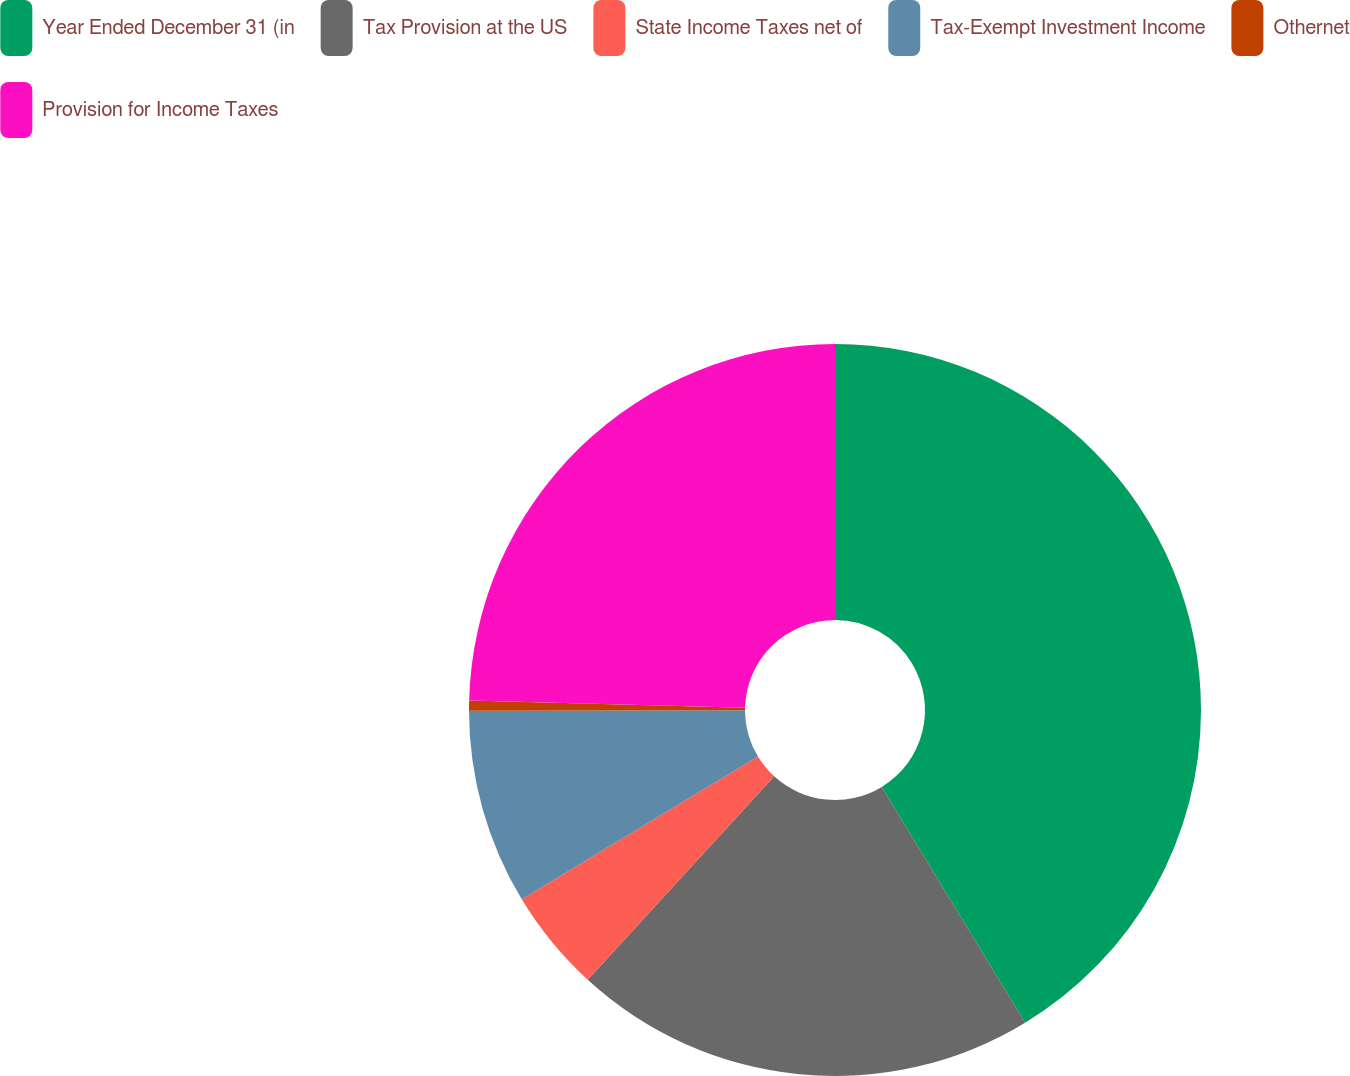Convert chart. <chart><loc_0><loc_0><loc_500><loc_500><pie_chart><fcel>Year Ended December 31 (in<fcel>Tax Provision at the US<fcel>State Income Taxes net of<fcel>Tax-Exempt Investment Income<fcel>Othernet<fcel>Provision for Income Taxes<nl><fcel>41.3%<fcel>20.5%<fcel>4.54%<fcel>8.62%<fcel>0.45%<fcel>24.58%<nl></chart> 